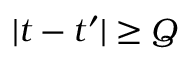<formula> <loc_0><loc_0><loc_500><loc_500>| t - t ^ { \prime } | \geq Q</formula> 